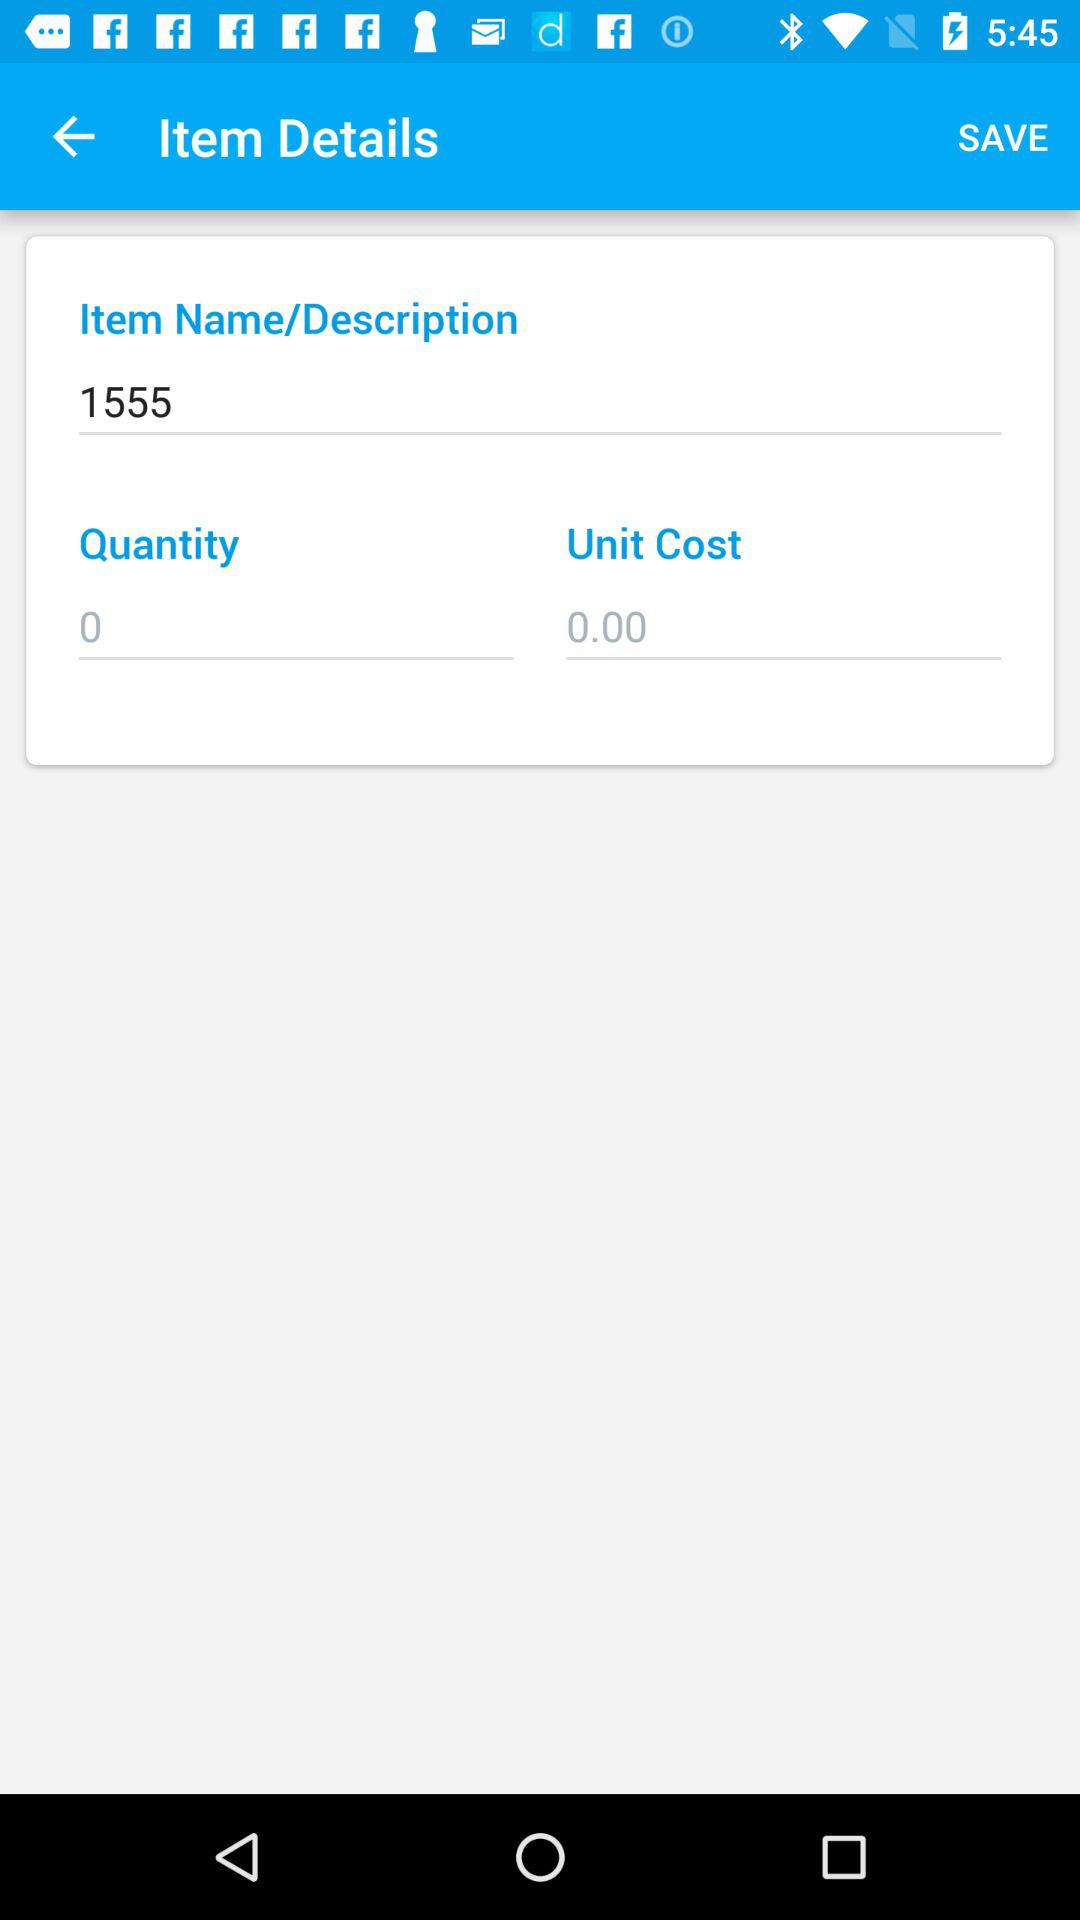How many items are being ordered?
Answer the question using a single word or phrase. 0 